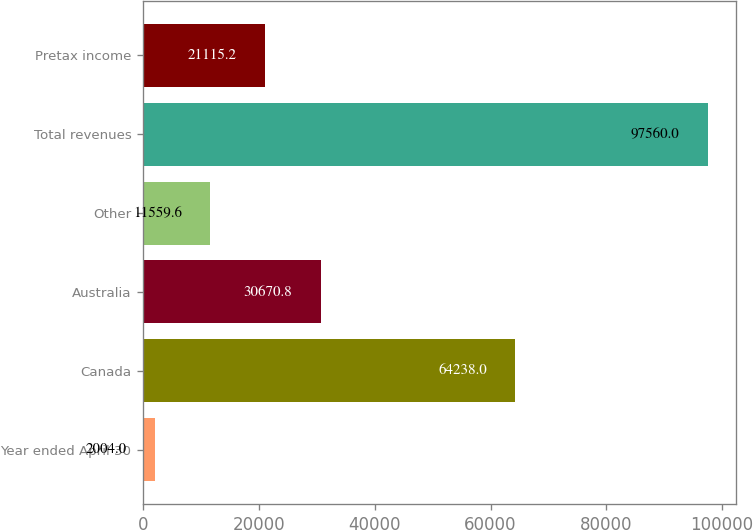<chart> <loc_0><loc_0><loc_500><loc_500><bar_chart><fcel>Year ended April 30<fcel>Canada<fcel>Australia<fcel>Other<fcel>Total revenues<fcel>Pretax income<nl><fcel>2004<fcel>64238<fcel>30670.8<fcel>11559.6<fcel>97560<fcel>21115.2<nl></chart> 